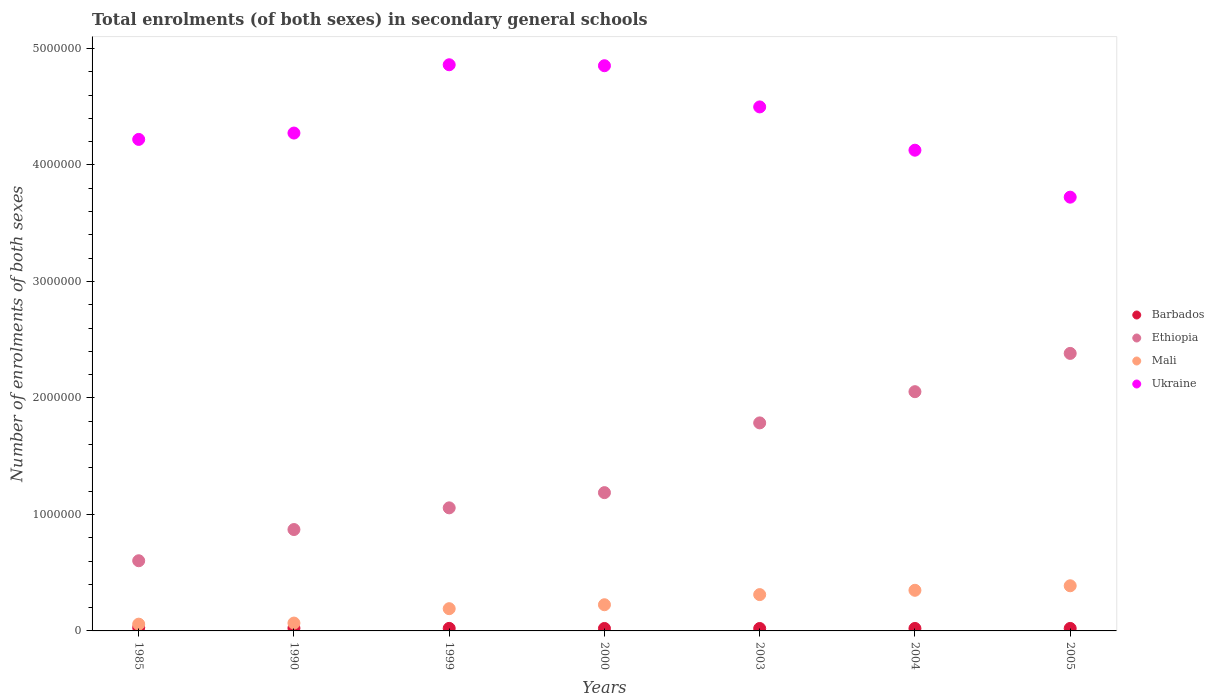Is the number of dotlines equal to the number of legend labels?
Keep it short and to the point. Yes. What is the number of enrolments in secondary schools in Ukraine in 2005?
Offer a very short reply. 3.72e+06. Across all years, what is the maximum number of enrolments in secondary schools in Ethiopia?
Your answer should be very brief. 2.38e+06. Across all years, what is the minimum number of enrolments in secondary schools in Mali?
Give a very brief answer. 5.81e+04. In which year was the number of enrolments in secondary schools in Ethiopia maximum?
Make the answer very short. 2005. What is the total number of enrolments in secondary schools in Barbados in the graph?
Your answer should be very brief. 1.59e+05. What is the difference between the number of enrolments in secondary schools in Mali in 2003 and that in 2005?
Your response must be concise. -7.58e+04. What is the difference between the number of enrolments in secondary schools in Ukraine in 2004 and the number of enrolments in secondary schools in Barbados in 1999?
Your answer should be compact. 4.10e+06. What is the average number of enrolments in secondary schools in Ukraine per year?
Your response must be concise. 4.36e+06. In the year 2004, what is the difference between the number of enrolments in secondary schools in Ethiopia and number of enrolments in secondary schools in Mali?
Provide a short and direct response. 1.70e+06. What is the ratio of the number of enrolments in secondary schools in Ethiopia in 2004 to that in 2005?
Your answer should be compact. 0.86. Is the number of enrolments in secondary schools in Ethiopia in 1999 less than that in 2000?
Offer a terse response. Yes. Is the difference between the number of enrolments in secondary schools in Ethiopia in 1985 and 2004 greater than the difference between the number of enrolments in secondary schools in Mali in 1985 and 2004?
Offer a terse response. No. What is the difference between the highest and the second highest number of enrolments in secondary schools in Mali?
Provide a short and direct response. 3.88e+04. What is the difference between the highest and the lowest number of enrolments in secondary schools in Mali?
Your answer should be compact. 3.29e+05. In how many years, is the number of enrolments in secondary schools in Mali greater than the average number of enrolments in secondary schools in Mali taken over all years?
Offer a very short reply. 3. Is the sum of the number of enrolments in secondary schools in Mali in 2003 and 2005 greater than the maximum number of enrolments in secondary schools in Ukraine across all years?
Give a very brief answer. No. Is it the case that in every year, the sum of the number of enrolments in secondary schools in Ethiopia and number of enrolments in secondary schools in Barbados  is greater than the number of enrolments in secondary schools in Mali?
Provide a short and direct response. Yes. Does the number of enrolments in secondary schools in Ethiopia monotonically increase over the years?
Make the answer very short. Yes. Is the number of enrolments in secondary schools in Ukraine strictly less than the number of enrolments in secondary schools in Barbados over the years?
Offer a terse response. No. How many years are there in the graph?
Ensure brevity in your answer.  7. What is the difference between two consecutive major ticks on the Y-axis?
Provide a short and direct response. 1.00e+06. Are the values on the major ticks of Y-axis written in scientific E-notation?
Ensure brevity in your answer.  No. Does the graph contain any zero values?
Offer a very short reply. No. Where does the legend appear in the graph?
Provide a succinct answer. Center right. What is the title of the graph?
Your answer should be compact. Total enrolments (of both sexes) in secondary general schools. Does "Bulgaria" appear as one of the legend labels in the graph?
Provide a succinct answer. No. What is the label or title of the X-axis?
Keep it short and to the point. Years. What is the label or title of the Y-axis?
Your answer should be compact. Number of enrolments of both sexes. What is the Number of enrolments of both sexes in Barbados in 1985?
Give a very brief answer. 2.87e+04. What is the Number of enrolments of both sexes in Ethiopia in 1985?
Keep it short and to the point. 6.02e+05. What is the Number of enrolments of both sexes of Mali in 1985?
Keep it short and to the point. 5.81e+04. What is the Number of enrolments of both sexes of Ukraine in 1985?
Ensure brevity in your answer.  4.22e+06. What is the Number of enrolments of both sexes of Barbados in 1990?
Your answer should be very brief. 2.40e+04. What is the Number of enrolments of both sexes of Ethiopia in 1990?
Give a very brief answer. 8.70e+05. What is the Number of enrolments of both sexes of Mali in 1990?
Offer a very short reply. 6.73e+04. What is the Number of enrolments of both sexes in Ukraine in 1990?
Your answer should be compact. 4.27e+06. What is the Number of enrolments of both sexes in Barbados in 1999?
Keep it short and to the point. 2.18e+04. What is the Number of enrolments of both sexes in Ethiopia in 1999?
Keep it short and to the point. 1.06e+06. What is the Number of enrolments of both sexes of Mali in 1999?
Your answer should be compact. 1.91e+05. What is the Number of enrolments of both sexes of Ukraine in 1999?
Your answer should be compact. 4.86e+06. What is the Number of enrolments of both sexes in Barbados in 2000?
Give a very brief answer. 2.10e+04. What is the Number of enrolments of both sexes of Ethiopia in 2000?
Provide a short and direct response. 1.19e+06. What is the Number of enrolments of both sexes of Mali in 2000?
Provide a succinct answer. 2.25e+05. What is the Number of enrolments of both sexes in Ukraine in 2000?
Offer a terse response. 4.85e+06. What is the Number of enrolments of both sexes in Barbados in 2003?
Your response must be concise. 2.08e+04. What is the Number of enrolments of both sexes of Ethiopia in 2003?
Your answer should be very brief. 1.79e+06. What is the Number of enrolments of both sexes in Mali in 2003?
Keep it short and to the point. 3.12e+05. What is the Number of enrolments of both sexes in Ukraine in 2003?
Your answer should be compact. 4.50e+06. What is the Number of enrolments of both sexes in Barbados in 2004?
Offer a very short reply. 2.12e+04. What is the Number of enrolments of both sexes of Ethiopia in 2004?
Your answer should be very brief. 2.05e+06. What is the Number of enrolments of both sexes of Mali in 2004?
Ensure brevity in your answer.  3.49e+05. What is the Number of enrolments of both sexes of Ukraine in 2004?
Make the answer very short. 4.13e+06. What is the Number of enrolments of both sexes of Barbados in 2005?
Your answer should be very brief. 2.13e+04. What is the Number of enrolments of both sexes of Ethiopia in 2005?
Ensure brevity in your answer.  2.38e+06. What is the Number of enrolments of both sexes of Mali in 2005?
Offer a very short reply. 3.88e+05. What is the Number of enrolments of both sexes in Ukraine in 2005?
Provide a short and direct response. 3.72e+06. Across all years, what is the maximum Number of enrolments of both sexes in Barbados?
Give a very brief answer. 2.87e+04. Across all years, what is the maximum Number of enrolments of both sexes of Ethiopia?
Your answer should be compact. 2.38e+06. Across all years, what is the maximum Number of enrolments of both sexes of Mali?
Give a very brief answer. 3.88e+05. Across all years, what is the maximum Number of enrolments of both sexes in Ukraine?
Keep it short and to the point. 4.86e+06. Across all years, what is the minimum Number of enrolments of both sexes of Barbados?
Offer a terse response. 2.08e+04. Across all years, what is the minimum Number of enrolments of both sexes in Ethiopia?
Give a very brief answer. 6.02e+05. Across all years, what is the minimum Number of enrolments of both sexes of Mali?
Provide a short and direct response. 5.81e+04. Across all years, what is the minimum Number of enrolments of both sexes of Ukraine?
Provide a succinct answer. 3.72e+06. What is the total Number of enrolments of both sexes of Barbados in the graph?
Make the answer very short. 1.59e+05. What is the total Number of enrolments of both sexes of Ethiopia in the graph?
Offer a terse response. 9.94e+06. What is the total Number of enrolments of both sexes in Mali in the graph?
Give a very brief answer. 1.59e+06. What is the total Number of enrolments of both sexes in Ukraine in the graph?
Your answer should be compact. 3.06e+07. What is the difference between the Number of enrolments of both sexes in Barbados in 1985 and that in 1990?
Give a very brief answer. 4691. What is the difference between the Number of enrolments of both sexes in Ethiopia in 1985 and that in 1990?
Provide a succinct answer. -2.68e+05. What is the difference between the Number of enrolments of both sexes of Mali in 1985 and that in 1990?
Your response must be concise. -9262. What is the difference between the Number of enrolments of both sexes of Ukraine in 1985 and that in 1990?
Give a very brief answer. -5.45e+04. What is the difference between the Number of enrolments of both sexes in Barbados in 1985 and that in 1999?
Your response must be concise. 6854. What is the difference between the Number of enrolments of both sexes of Ethiopia in 1985 and that in 1999?
Make the answer very short. -4.54e+05. What is the difference between the Number of enrolments of both sexes in Mali in 1985 and that in 1999?
Ensure brevity in your answer.  -1.33e+05. What is the difference between the Number of enrolments of both sexes in Ukraine in 1985 and that in 1999?
Ensure brevity in your answer.  -6.41e+05. What is the difference between the Number of enrolments of both sexes in Barbados in 1985 and that in 2000?
Offer a very short reply. 7679. What is the difference between the Number of enrolments of both sexes of Ethiopia in 1985 and that in 2000?
Offer a terse response. -5.85e+05. What is the difference between the Number of enrolments of both sexes in Mali in 1985 and that in 2000?
Provide a short and direct response. -1.67e+05. What is the difference between the Number of enrolments of both sexes of Ukraine in 1985 and that in 2000?
Offer a terse response. -6.32e+05. What is the difference between the Number of enrolments of both sexes in Barbados in 1985 and that in 2003?
Provide a succinct answer. 7857. What is the difference between the Number of enrolments of both sexes in Ethiopia in 1985 and that in 2003?
Make the answer very short. -1.18e+06. What is the difference between the Number of enrolments of both sexes in Mali in 1985 and that in 2003?
Provide a succinct answer. -2.54e+05. What is the difference between the Number of enrolments of both sexes in Ukraine in 1985 and that in 2003?
Provide a succinct answer. -2.79e+05. What is the difference between the Number of enrolments of both sexes in Barbados in 1985 and that in 2004?
Your answer should be compact. 7473. What is the difference between the Number of enrolments of both sexes in Ethiopia in 1985 and that in 2004?
Provide a short and direct response. -1.45e+06. What is the difference between the Number of enrolments of both sexes in Mali in 1985 and that in 2004?
Make the answer very short. -2.91e+05. What is the difference between the Number of enrolments of both sexes of Ukraine in 1985 and that in 2004?
Give a very brief answer. 9.27e+04. What is the difference between the Number of enrolments of both sexes of Barbados in 1985 and that in 2005?
Your response must be concise. 7350. What is the difference between the Number of enrolments of both sexes of Ethiopia in 1985 and that in 2005?
Provide a short and direct response. -1.78e+06. What is the difference between the Number of enrolments of both sexes of Mali in 1985 and that in 2005?
Provide a short and direct response. -3.29e+05. What is the difference between the Number of enrolments of both sexes in Ukraine in 1985 and that in 2005?
Your answer should be very brief. 4.96e+05. What is the difference between the Number of enrolments of both sexes in Barbados in 1990 and that in 1999?
Offer a very short reply. 2163. What is the difference between the Number of enrolments of both sexes in Ethiopia in 1990 and that in 1999?
Keep it short and to the point. -1.86e+05. What is the difference between the Number of enrolments of both sexes in Mali in 1990 and that in 1999?
Provide a short and direct response. -1.24e+05. What is the difference between the Number of enrolments of both sexes of Ukraine in 1990 and that in 1999?
Your answer should be compact. -5.86e+05. What is the difference between the Number of enrolments of both sexes in Barbados in 1990 and that in 2000?
Keep it short and to the point. 2988. What is the difference between the Number of enrolments of both sexes in Ethiopia in 1990 and that in 2000?
Provide a short and direct response. -3.17e+05. What is the difference between the Number of enrolments of both sexes in Mali in 1990 and that in 2000?
Give a very brief answer. -1.57e+05. What is the difference between the Number of enrolments of both sexes of Ukraine in 1990 and that in 2000?
Give a very brief answer. -5.78e+05. What is the difference between the Number of enrolments of both sexes of Barbados in 1990 and that in 2003?
Provide a short and direct response. 3166. What is the difference between the Number of enrolments of both sexes of Ethiopia in 1990 and that in 2003?
Offer a terse response. -9.15e+05. What is the difference between the Number of enrolments of both sexes in Mali in 1990 and that in 2003?
Provide a succinct answer. -2.44e+05. What is the difference between the Number of enrolments of both sexes of Ukraine in 1990 and that in 2003?
Ensure brevity in your answer.  -2.24e+05. What is the difference between the Number of enrolments of both sexes in Barbados in 1990 and that in 2004?
Make the answer very short. 2782. What is the difference between the Number of enrolments of both sexes in Ethiopia in 1990 and that in 2004?
Your answer should be very brief. -1.18e+06. What is the difference between the Number of enrolments of both sexes of Mali in 1990 and that in 2004?
Provide a succinct answer. -2.81e+05. What is the difference between the Number of enrolments of both sexes of Ukraine in 1990 and that in 2004?
Make the answer very short. 1.47e+05. What is the difference between the Number of enrolments of both sexes of Barbados in 1990 and that in 2005?
Your answer should be compact. 2659. What is the difference between the Number of enrolments of both sexes of Ethiopia in 1990 and that in 2005?
Give a very brief answer. -1.51e+06. What is the difference between the Number of enrolments of both sexes in Mali in 1990 and that in 2005?
Your answer should be compact. -3.20e+05. What is the difference between the Number of enrolments of both sexes in Ukraine in 1990 and that in 2005?
Offer a terse response. 5.50e+05. What is the difference between the Number of enrolments of both sexes of Barbados in 1999 and that in 2000?
Your answer should be very brief. 825. What is the difference between the Number of enrolments of both sexes of Ethiopia in 1999 and that in 2000?
Provide a succinct answer. -1.31e+05. What is the difference between the Number of enrolments of both sexes of Mali in 1999 and that in 2000?
Ensure brevity in your answer.  -3.38e+04. What is the difference between the Number of enrolments of both sexes of Ukraine in 1999 and that in 2000?
Your answer should be very brief. 8251. What is the difference between the Number of enrolments of both sexes of Barbados in 1999 and that in 2003?
Give a very brief answer. 1003. What is the difference between the Number of enrolments of both sexes of Ethiopia in 1999 and that in 2003?
Give a very brief answer. -7.29e+05. What is the difference between the Number of enrolments of both sexes of Mali in 1999 and that in 2003?
Make the answer very short. -1.21e+05. What is the difference between the Number of enrolments of both sexes of Ukraine in 1999 and that in 2003?
Provide a succinct answer. 3.62e+05. What is the difference between the Number of enrolments of both sexes of Barbados in 1999 and that in 2004?
Make the answer very short. 619. What is the difference between the Number of enrolments of both sexes in Ethiopia in 1999 and that in 2004?
Make the answer very short. -9.97e+05. What is the difference between the Number of enrolments of both sexes of Mali in 1999 and that in 2004?
Ensure brevity in your answer.  -1.58e+05. What is the difference between the Number of enrolments of both sexes in Ukraine in 1999 and that in 2004?
Offer a terse response. 7.33e+05. What is the difference between the Number of enrolments of both sexes of Barbados in 1999 and that in 2005?
Make the answer very short. 496. What is the difference between the Number of enrolments of both sexes of Ethiopia in 1999 and that in 2005?
Your answer should be very brief. -1.33e+06. What is the difference between the Number of enrolments of both sexes of Mali in 1999 and that in 2005?
Keep it short and to the point. -1.97e+05. What is the difference between the Number of enrolments of both sexes in Ukraine in 1999 and that in 2005?
Make the answer very short. 1.14e+06. What is the difference between the Number of enrolments of both sexes in Barbados in 2000 and that in 2003?
Your answer should be compact. 178. What is the difference between the Number of enrolments of both sexes in Ethiopia in 2000 and that in 2003?
Your answer should be compact. -5.99e+05. What is the difference between the Number of enrolments of both sexes in Mali in 2000 and that in 2003?
Offer a very short reply. -8.70e+04. What is the difference between the Number of enrolments of both sexes in Ukraine in 2000 and that in 2003?
Provide a succinct answer. 3.54e+05. What is the difference between the Number of enrolments of both sexes of Barbados in 2000 and that in 2004?
Provide a succinct answer. -206. What is the difference between the Number of enrolments of both sexes in Ethiopia in 2000 and that in 2004?
Provide a succinct answer. -8.67e+05. What is the difference between the Number of enrolments of both sexes in Mali in 2000 and that in 2004?
Give a very brief answer. -1.24e+05. What is the difference between the Number of enrolments of both sexes of Ukraine in 2000 and that in 2004?
Offer a very short reply. 7.25e+05. What is the difference between the Number of enrolments of both sexes of Barbados in 2000 and that in 2005?
Your answer should be very brief. -329. What is the difference between the Number of enrolments of both sexes in Ethiopia in 2000 and that in 2005?
Keep it short and to the point. -1.20e+06. What is the difference between the Number of enrolments of both sexes of Mali in 2000 and that in 2005?
Give a very brief answer. -1.63e+05. What is the difference between the Number of enrolments of both sexes of Ukraine in 2000 and that in 2005?
Your answer should be very brief. 1.13e+06. What is the difference between the Number of enrolments of both sexes in Barbados in 2003 and that in 2004?
Your answer should be compact. -384. What is the difference between the Number of enrolments of both sexes in Ethiopia in 2003 and that in 2004?
Offer a terse response. -2.68e+05. What is the difference between the Number of enrolments of both sexes of Mali in 2003 and that in 2004?
Provide a short and direct response. -3.70e+04. What is the difference between the Number of enrolments of both sexes in Ukraine in 2003 and that in 2004?
Offer a very short reply. 3.72e+05. What is the difference between the Number of enrolments of both sexes in Barbados in 2003 and that in 2005?
Make the answer very short. -507. What is the difference between the Number of enrolments of both sexes of Ethiopia in 2003 and that in 2005?
Your answer should be compact. -5.96e+05. What is the difference between the Number of enrolments of both sexes in Mali in 2003 and that in 2005?
Provide a short and direct response. -7.58e+04. What is the difference between the Number of enrolments of both sexes of Ukraine in 2003 and that in 2005?
Your response must be concise. 7.75e+05. What is the difference between the Number of enrolments of both sexes in Barbados in 2004 and that in 2005?
Ensure brevity in your answer.  -123. What is the difference between the Number of enrolments of both sexes of Ethiopia in 2004 and that in 2005?
Make the answer very short. -3.29e+05. What is the difference between the Number of enrolments of both sexes in Mali in 2004 and that in 2005?
Your answer should be very brief. -3.88e+04. What is the difference between the Number of enrolments of both sexes of Ukraine in 2004 and that in 2005?
Your response must be concise. 4.03e+05. What is the difference between the Number of enrolments of both sexes of Barbados in 1985 and the Number of enrolments of both sexes of Ethiopia in 1990?
Give a very brief answer. -8.42e+05. What is the difference between the Number of enrolments of both sexes of Barbados in 1985 and the Number of enrolments of both sexes of Mali in 1990?
Offer a very short reply. -3.86e+04. What is the difference between the Number of enrolments of both sexes of Barbados in 1985 and the Number of enrolments of both sexes of Ukraine in 1990?
Your answer should be very brief. -4.24e+06. What is the difference between the Number of enrolments of both sexes of Ethiopia in 1985 and the Number of enrolments of both sexes of Mali in 1990?
Your answer should be compact. 5.35e+05. What is the difference between the Number of enrolments of both sexes of Ethiopia in 1985 and the Number of enrolments of both sexes of Ukraine in 1990?
Give a very brief answer. -3.67e+06. What is the difference between the Number of enrolments of both sexes of Mali in 1985 and the Number of enrolments of both sexes of Ukraine in 1990?
Provide a short and direct response. -4.22e+06. What is the difference between the Number of enrolments of both sexes of Barbados in 1985 and the Number of enrolments of both sexes of Ethiopia in 1999?
Your answer should be very brief. -1.03e+06. What is the difference between the Number of enrolments of both sexes of Barbados in 1985 and the Number of enrolments of both sexes of Mali in 1999?
Keep it short and to the point. -1.62e+05. What is the difference between the Number of enrolments of both sexes in Barbados in 1985 and the Number of enrolments of both sexes in Ukraine in 1999?
Your response must be concise. -4.83e+06. What is the difference between the Number of enrolments of both sexes in Ethiopia in 1985 and the Number of enrolments of both sexes in Mali in 1999?
Your response must be concise. 4.11e+05. What is the difference between the Number of enrolments of both sexes in Ethiopia in 1985 and the Number of enrolments of both sexes in Ukraine in 1999?
Offer a terse response. -4.26e+06. What is the difference between the Number of enrolments of both sexes in Mali in 1985 and the Number of enrolments of both sexes in Ukraine in 1999?
Keep it short and to the point. -4.80e+06. What is the difference between the Number of enrolments of both sexes of Barbados in 1985 and the Number of enrolments of both sexes of Ethiopia in 2000?
Provide a succinct answer. -1.16e+06. What is the difference between the Number of enrolments of both sexes of Barbados in 1985 and the Number of enrolments of both sexes of Mali in 2000?
Provide a succinct answer. -1.96e+05. What is the difference between the Number of enrolments of both sexes in Barbados in 1985 and the Number of enrolments of both sexes in Ukraine in 2000?
Give a very brief answer. -4.82e+06. What is the difference between the Number of enrolments of both sexes of Ethiopia in 1985 and the Number of enrolments of both sexes of Mali in 2000?
Give a very brief answer. 3.78e+05. What is the difference between the Number of enrolments of both sexes of Ethiopia in 1985 and the Number of enrolments of both sexes of Ukraine in 2000?
Provide a succinct answer. -4.25e+06. What is the difference between the Number of enrolments of both sexes in Mali in 1985 and the Number of enrolments of both sexes in Ukraine in 2000?
Offer a very short reply. -4.79e+06. What is the difference between the Number of enrolments of both sexes in Barbados in 1985 and the Number of enrolments of both sexes in Ethiopia in 2003?
Keep it short and to the point. -1.76e+06. What is the difference between the Number of enrolments of both sexes of Barbados in 1985 and the Number of enrolments of both sexes of Mali in 2003?
Ensure brevity in your answer.  -2.83e+05. What is the difference between the Number of enrolments of both sexes in Barbados in 1985 and the Number of enrolments of both sexes in Ukraine in 2003?
Offer a terse response. -4.47e+06. What is the difference between the Number of enrolments of both sexes in Ethiopia in 1985 and the Number of enrolments of both sexes in Mali in 2003?
Ensure brevity in your answer.  2.91e+05. What is the difference between the Number of enrolments of both sexes in Ethiopia in 1985 and the Number of enrolments of both sexes in Ukraine in 2003?
Your response must be concise. -3.90e+06. What is the difference between the Number of enrolments of both sexes of Mali in 1985 and the Number of enrolments of both sexes of Ukraine in 2003?
Offer a very short reply. -4.44e+06. What is the difference between the Number of enrolments of both sexes in Barbados in 1985 and the Number of enrolments of both sexes in Ethiopia in 2004?
Keep it short and to the point. -2.02e+06. What is the difference between the Number of enrolments of both sexes of Barbados in 1985 and the Number of enrolments of both sexes of Mali in 2004?
Provide a succinct answer. -3.20e+05. What is the difference between the Number of enrolments of both sexes in Barbados in 1985 and the Number of enrolments of both sexes in Ukraine in 2004?
Provide a succinct answer. -4.10e+06. What is the difference between the Number of enrolments of both sexes in Ethiopia in 1985 and the Number of enrolments of both sexes in Mali in 2004?
Make the answer very short. 2.54e+05. What is the difference between the Number of enrolments of both sexes of Ethiopia in 1985 and the Number of enrolments of both sexes of Ukraine in 2004?
Give a very brief answer. -3.52e+06. What is the difference between the Number of enrolments of both sexes of Mali in 1985 and the Number of enrolments of both sexes of Ukraine in 2004?
Ensure brevity in your answer.  -4.07e+06. What is the difference between the Number of enrolments of both sexes in Barbados in 1985 and the Number of enrolments of both sexes in Ethiopia in 2005?
Give a very brief answer. -2.35e+06. What is the difference between the Number of enrolments of both sexes in Barbados in 1985 and the Number of enrolments of both sexes in Mali in 2005?
Offer a terse response. -3.59e+05. What is the difference between the Number of enrolments of both sexes of Barbados in 1985 and the Number of enrolments of both sexes of Ukraine in 2005?
Your response must be concise. -3.69e+06. What is the difference between the Number of enrolments of both sexes of Ethiopia in 1985 and the Number of enrolments of both sexes of Mali in 2005?
Give a very brief answer. 2.15e+05. What is the difference between the Number of enrolments of both sexes in Ethiopia in 1985 and the Number of enrolments of both sexes in Ukraine in 2005?
Make the answer very short. -3.12e+06. What is the difference between the Number of enrolments of both sexes in Mali in 1985 and the Number of enrolments of both sexes in Ukraine in 2005?
Provide a short and direct response. -3.67e+06. What is the difference between the Number of enrolments of both sexes in Barbados in 1990 and the Number of enrolments of both sexes in Ethiopia in 1999?
Offer a very short reply. -1.03e+06. What is the difference between the Number of enrolments of both sexes in Barbados in 1990 and the Number of enrolments of both sexes in Mali in 1999?
Offer a terse response. -1.67e+05. What is the difference between the Number of enrolments of both sexes in Barbados in 1990 and the Number of enrolments of both sexes in Ukraine in 1999?
Provide a succinct answer. -4.84e+06. What is the difference between the Number of enrolments of both sexes of Ethiopia in 1990 and the Number of enrolments of both sexes of Mali in 1999?
Your response must be concise. 6.79e+05. What is the difference between the Number of enrolments of both sexes in Ethiopia in 1990 and the Number of enrolments of both sexes in Ukraine in 1999?
Your response must be concise. -3.99e+06. What is the difference between the Number of enrolments of both sexes of Mali in 1990 and the Number of enrolments of both sexes of Ukraine in 1999?
Keep it short and to the point. -4.79e+06. What is the difference between the Number of enrolments of both sexes of Barbados in 1990 and the Number of enrolments of both sexes of Ethiopia in 2000?
Make the answer very short. -1.16e+06. What is the difference between the Number of enrolments of both sexes in Barbados in 1990 and the Number of enrolments of both sexes in Mali in 2000?
Offer a terse response. -2.01e+05. What is the difference between the Number of enrolments of both sexes in Barbados in 1990 and the Number of enrolments of both sexes in Ukraine in 2000?
Ensure brevity in your answer.  -4.83e+06. What is the difference between the Number of enrolments of both sexes in Ethiopia in 1990 and the Number of enrolments of both sexes in Mali in 2000?
Ensure brevity in your answer.  6.46e+05. What is the difference between the Number of enrolments of both sexes in Ethiopia in 1990 and the Number of enrolments of both sexes in Ukraine in 2000?
Your answer should be very brief. -3.98e+06. What is the difference between the Number of enrolments of both sexes of Mali in 1990 and the Number of enrolments of both sexes of Ukraine in 2000?
Offer a terse response. -4.78e+06. What is the difference between the Number of enrolments of both sexes in Barbados in 1990 and the Number of enrolments of both sexes in Ethiopia in 2003?
Keep it short and to the point. -1.76e+06. What is the difference between the Number of enrolments of both sexes in Barbados in 1990 and the Number of enrolments of both sexes in Mali in 2003?
Ensure brevity in your answer.  -2.88e+05. What is the difference between the Number of enrolments of both sexes in Barbados in 1990 and the Number of enrolments of both sexes in Ukraine in 2003?
Offer a terse response. -4.47e+06. What is the difference between the Number of enrolments of both sexes of Ethiopia in 1990 and the Number of enrolments of both sexes of Mali in 2003?
Keep it short and to the point. 5.59e+05. What is the difference between the Number of enrolments of both sexes in Ethiopia in 1990 and the Number of enrolments of both sexes in Ukraine in 2003?
Give a very brief answer. -3.63e+06. What is the difference between the Number of enrolments of both sexes of Mali in 1990 and the Number of enrolments of both sexes of Ukraine in 2003?
Ensure brevity in your answer.  -4.43e+06. What is the difference between the Number of enrolments of both sexes of Barbados in 1990 and the Number of enrolments of both sexes of Ethiopia in 2004?
Make the answer very short. -2.03e+06. What is the difference between the Number of enrolments of both sexes of Barbados in 1990 and the Number of enrolments of both sexes of Mali in 2004?
Offer a very short reply. -3.25e+05. What is the difference between the Number of enrolments of both sexes of Barbados in 1990 and the Number of enrolments of both sexes of Ukraine in 2004?
Ensure brevity in your answer.  -4.10e+06. What is the difference between the Number of enrolments of both sexes in Ethiopia in 1990 and the Number of enrolments of both sexes in Mali in 2004?
Your response must be concise. 5.22e+05. What is the difference between the Number of enrolments of both sexes of Ethiopia in 1990 and the Number of enrolments of both sexes of Ukraine in 2004?
Your answer should be compact. -3.26e+06. What is the difference between the Number of enrolments of both sexes of Mali in 1990 and the Number of enrolments of both sexes of Ukraine in 2004?
Give a very brief answer. -4.06e+06. What is the difference between the Number of enrolments of both sexes in Barbados in 1990 and the Number of enrolments of both sexes in Ethiopia in 2005?
Offer a very short reply. -2.36e+06. What is the difference between the Number of enrolments of both sexes in Barbados in 1990 and the Number of enrolments of both sexes in Mali in 2005?
Give a very brief answer. -3.64e+05. What is the difference between the Number of enrolments of both sexes in Barbados in 1990 and the Number of enrolments of both sexes in Ukraine in 2005?
Your answer should be very brief. -3.70e+06. What is the difference between the Number of enrolments of both sexes of Ethiopia in 1990 and the Number of enrolments of both sexes of Mali in 2005?
Your answer should be very brief. 4.83e+05. What is the difference between the Number of enrolments of both sexes of Ethiopia in 1990 and the Number of enrolments of both sexes of Ukraine in 2005?
Your response must be concise. -2.85e+06. What is the difference between the Number of enrolments of both sexes in Mali in 1990 and the Number of enrolments of both sexes in Ukraine in 2005?
Offer a very short reply. -3.66e+06. What is the difference between the Number of enrolments of both sexes of Barbados in 1999 and the Number of enrolments of both sexes of Ethiopia in 2000?
Give a very brief answer. -1.17e+06. What is the difference between the Number of enrolments of both sexes in Barbados in 1999 and the Number of enrolments of both sexes in Mali in 2000?
Your response must be concise. -2.03e+05. What is the difference between the Number of enrolments of both sexes in Barbados in 1999 and the Number of enrolments of both sexes in Ukraine in 2000?
Make the answer very short. -4.83e+06. What is the difference between the Number of enrolments of both sexes of Ethiopia in 1999 and the Number of enrolments of both sexes of Mali in 2000?
Keep it short and to the point. 8.32e+05. What is the difference between the Number of enrolments of both sexes of Ethiopia in 1999 and the Number of enrolments of both sexes of Ukraine in 2000?
Offer a very short reply. -3.80e+06. What is the difference between the Number of enrolments of both sexes in Mali in 1999 and the Number of enrolments of both sexes in Ukraine in 2000?
Make the answer very short. -4.66e+06. What is the difference between the Number of enrolments of both sexes in Barbados in 1999 and the Number of enrolments of both sexes in Ethiopia in 2003?
Give a very brief answer. -1.76e+06. What is the difference between the Number of enrolments of both sexes of Barbados in 1999 and the Number of enrolments of both sexes of Mali in 2003?
Your response must be concise. -2.90e+05. What is the difference between the Number of enrolments of both sexes of Barbados in 1999 and the Number of enrolments of both sexes of Ukraine in 2003?
Offer a very short reply. -4.48e+06. What is the difference between the Number of enrolments of both sexes in Ethiopia in 1999 and the Number of enrolments of both sexes in Mali in 2003?
Provide a succinct answer. 7.45e+05. What is the difference between the Number of enrolments of both sexes of Ethiopia in 1999 and the Number of enrolments of both sexes of Ukraine in 2003?
Make the answer very short. -3.44e+06. What is the difference between the Number of enrolments of both sexes in Mali in 1999 and the Number of enrolments of both sexes in Ukraine in 2003?
Your response must be concise. -4.31e+06. What is the difference between the Number of enrolments of both sexes of Barbados in 1999 and the Number of enrolments of both sexes of Ethiopia in 2004?
Keep it short and to the point. -2.03e+06. What is the difference between the Number of enrolments of both sexes in Barbados in 1999 and the Number of enrolments of both sexes in Mali in 2004?
Make the answer very short. -3.27e+05. What is the difference between the Number of enrolments of both sexes of Barbados in 1999 and the Number of enrolments of both sexes of Ukraine in 2004?
Your answer should be very brief. -4.10e+06. What is the difference between the Number of enrolments of both sexes in Ethiopia in 1999 and the Number of enrolments of both sexes in Mali in 2004?
Keep it short and to the point. 7.08e+05. What is the difference between the Number of enrolments of both sexes of Ethiopia in 1999 and the Number of enrolments of both sexes of Ukraine in 2004?
Make the answer very short. -3.07e+06. What is the difference between the Number of enrolments of both sexes of Mali in 1999 and the Number of enrolments of both sexes of Ukraine in 2004?
Your response must be concise. -3.94e+06. What is the difference between the Number of enrolments of both sexes of Barbados in 1999 and the Number of enrolments of both sexes of Ethiopia in 2005?
Provide a short and direct response. -2.36e+06. What is the difference between the Number of enrolments of both sexes in Barbados in 1999 and the Number of enrolments of both sexes in Mali in 2005?
Your answer should be compact. -3.66e+05. What is the difference between the Number of enrolments of both sexes of Barbados in 1999 and the Number of enrolments of both sexes of Ukraine in 2005?
Offer a terse response. -3.70e+06. What is the difference between the Number of enrolments of both sexes in Ethiopia in 1999 and the Number of enrolments of both sexes in Mali in 2005?
Your response must be concise. 6.69e+05. What is the difference between the Number of enrolments of both sexes in Ethiopia in 1999 and the Number of enrolments of both sexes in Ukraine in 2005?
Provide a succinct answer. -2.67e+06. What is the difference between the Number of enrolments of both sexes in Mali in 1999 and the Number of enrolments of both sexes in Ukraine in 2005?
Provide a short and direct response. -3.53e+06. What is the difference between the Number of enrolments of both sexes in Barbados in 2000 and the Number of enrolments of both sexes in Ethiopia in 2003?
Offer a very short reply. -1.76e+06. What is the difference between the Number of enrolments of both sexes of Barbados in 2000 and the Number of enrolments of both sexes of Mali in 2003?
Offer a very short reply. -2.91e+05. What is the difference between the Number of enrolments of both sexes of Barbados in 2000 and the Number of enrolments of both sexes of Ukraine in 2003?
Ensure brevity in your answer.  -4.48e+06. What is the difference between the Number of enrolments of both sexes in Ethiopia in 2000 and the Number of enrolments of both sexes in Mali in 2003?
Offer a terse response. 8.75e+05. What is the difference between the Number of enrolments of both sexes of Ethiopia in 2000 and the Number of enrolments of both sexes of Ukraine in 2003?
Offer a very short reply. -3.31e+06. What is the difference between the Number of enrolments of both sexes in Mali in 2000 and the Number of enrolments of both sexes in Ukraine in 2003?
Provide a succinct answer. -4.27e+06. What is the difference between the Number of enrolments of both sexes of Barbados in 2000 and the Number of enrolments of both sexes of Ethiopia in 2004?
Your answer should be very brief. -2.03e+06. What is the difference between the Number of enrolments of both sexes of Barbados in 2000 and the Number of enrolments of both sexes of Mali in 2004?
Your answer should be compact. -3.28e+05. What is the difference between the Number of enrolments of both sexes in Barbados in 2000 and the Number of enrolments of both sexes in Ukraine in 2004?
Make the answer very short. -4.11e+06. What is the difference between the Number of enrolments of both sexes in Ethiopia in 2000 and the Number of enrolments of both sexes in Mali in 2004?
Offer a terse response. 8.38e+05. What is the difference between the Number of enrolments of both sexes in Ethiopia in 2000 and the Number of enrolments of both sexes in Ukraine in 2004?
Your response must be concise. -2.94e+06. What is the difference between the Number of enrolments of both sexes in Mali in 2000 and the Number of enrolments of both sexes in Ukraine in 2004?
Provide a succinct answer. -3.90e+06. What is the difference between the Number of enrolments of both sexes in Barbados in 2000 and the Number of enrolments of both sexes in Ethiopia in 2005?
Your answer should be very brief. -2.36e+06. What is the difference between the Number of enrolments of both sexes in Barbados in 2000 and the Number of enrolments of both sexes in Mali in 2005?
Offer a terse response. -3.67e+05. What is the difference between the Number of enrolments of both sexes of Barbados in 2000 and the Number of enrolments of both sexes of Ukraine in 2005?
Give a very brief answer. -3.70e+06. What is the difference between the Number of enrolments of both sexes of Ethiopia in 2000 and the Number of enrolments of both sexes of Mali in 2005?
Keep it short and to the point. 7.99e+05. What is the difference between the Number of enrolments of both sexes in Ethiopia in 2000 and the Number of enrolments of both sexes in Ukraine in 2005?
Provide a succinct answer. -2.54e+06. What is the difference between the Number of enrolments of both sexes in Mali in 2000 and the Number of enrolments of both sexes in Ukraine in 2005?
Offer a terse response. -3.50e+06. What is the difference between the Number of enrolments of both sexes in Barbados in 2003 and the Number of enrolments of both sexes in Ethiopia in 2004?
Provide a short and direct response. -2.03e+06. What is the difference between the Number of enrolments of both sexes of Barbados in 2003 and the Number of enrolments of both sexes of Mali in 2004?
Your answer should be compact. -3.28e+05. What is the difference between the Number of enrolments of both sexes of Barbados in 2003 and the Number of enrolments of both sexes of Ukraine in 2004?
Provide a succinct answer. -4.11e+06. What is the difference between the Number of enrolments of both sexes in Ethiopia in 2003 and the Number of enrolments of both sexes in Mali in 2004?
Offer a very short reply. 1.44e+06. What is the difference between the Number of enrolments of both sexes in Ethiopia in 2003 and the Number of enrolments of both sexes in Ukraine in 2004?
Your answer should be very brief. -2.34e+06. What is the difference between the Number of enrolments of both sexes of Mali in 2003 and the Number of enrolments of both sexes of Ukraine in 2004?
Offer a very short reply. -3.81e+06. What is the difference between the Number of enrolments of both sexes in Barbados in 2003 and the Number of enrolments of both sexes in Ethiopia in 2005?
Your answer should be compact. -2.36e+06. What is the difference between the Number of enrolments of both sexes in Barbados in 2003 and the Number of enrolments of both sexes in Mali in 2005?
Ensure brevity in your answer.  -3.67e+05. What is the difference between the Number of enrolments of both sexes of Barbados in 2003 and the Number of enrolments of both sexes of Ukraine in 2005?
Provide a short and direct response. -3.70e+06. What is the difference between the Number of enrolments of both sexes in Ethiopia in 2003 and the Number of enrolments of both sexes in Mali in 2005?
Your answer should be compact. 1.40e+06. What is the difference between the Number of enrolments of both sexes in Ethiopia in 2003 and the Number of enrolments of both sexes in Ukraine in 2005?
Provide a succinct answer. -1.94e+06. What is the difference between the Number of enrolments of both sexes in Mali in 2003 and the Number of enrolments of both sexes in Ukraine in 2005?
Ensure brevity in your answer.  -3.41e+06. What is the difference between the Number of enrolments of both sexes in Barbados in 2004 and the Number of enrolments of both sexes in Ethiopia in 2005?
Offer a very short reply. -2.36e+06. What is the difference between the Number of enrolments of both sexes in Barbados in 2004 and the Number of enrolments of both sexes in Mali in 2005?
Ensure brevity in your answer.  -3.66e+05. What is the difference between the Number of enrolments of both sexes of Barbados in 2004 and the Number of enrolments of both sexes of Ukraine in 2005?
Your response must be concise. -3.70e+06. What is the difference between the Number of enrolments of both sexes of Ethiopia in 2004 and the Number of enrolments of both sexes of Mali in 2005?
Your answer should be very brief. 1.67e+06. What is the difference between the Number of enrolments of both sexes of Ethiopia in 2004 and the Number of enrolments of both sexes of Ukraine in 2005?
Keep it short and to the point. -1.67e+06. What is the difference between the Number of enrolments of both sexes of Mali in 2004 and the Number of enrolments of both sexes of Ukraine in 2005?
Offer a very short reply. -3.37e+06. What is the average Number of enrolments of both sexes of Barbados per year?
Provide a short and direct response. 2.27e+04. What is the average Number of enrolments of both sexes in Ethiopia per year?
Keep it short and to the point. 1.42e+06. What is the average Number of enrolments of both sexes of Mali per year?
Provide a succinct answer. 2.27e+05. What is the average Number of enrolments of both sexes of Ukraine per year?
Offer a terse response. 4.36e+06. In the year 1985, what is the difference between the Number of enrolments of both sexes of Barbados and Number of enrolments of both sexes of Ethiopia?
Make the answer very short. -5.74e+05. In the year 1985, what is the difference between the Number of enrolments of both sexes in Barbados and Number of enrolments of both sexes in Mali?
Give a very brief answer. -2.94e+04. In the year 1985, what is the difference between the Number of enrolments of both sexes of Barbados and Number of enrolments of both sexes of Ukraine?
Give a very brief answer. -4.19e+06. In the year 1985, what is the difference between the Number of enrolments of both sexes of Ethiopia and Number of enrolments of both sexes of Mali?
Ensure brevity in your answer.  5.44e+05. In the year 1985, what is the difference between the Number of enrolments of both sexes of Ethiopia and Number of enrolments of both sexes of Ukraine?
Your answer should be compact. -3.62e+06. In the year 1985, what is the difference between the Number of enrolments of both sexes of Mali and Number of enrolments of both sexes of Ukraine?
Offer a very short reply. -4.16e+06. In the year 1990, what is the difference between the Number of enrolments of both sexes in Barbados and Number of enrolments of both sexes in Ethiopia?
Offer a terse response. -8.46e+05. In the year 1990, what is the difference between the Number of enrolments of both sexes of Barbados and Number of enrolments of both sexes of Mali?
Your answer should be compact. -4.33e+04. In the year 1990, what is the difference between the Number of enrolments of both sexes in Barbados and Number of enrolments of both sexes in Ukraine?
Keep it short and to the point. -4.25e+06. In the year 1990, what is the difference between the Number of enrolments of both sexes of Ethiopia and Number of enrolments of both sexes of Mali?
Offer a terse response. 8.03e+05. In the year 1990, what is the difference between the Number of enrolments of both sexes of Ethiopia and Number of enrolments of both sexes of Ukraine?
Your response must be concise. -3.40e+06. In the year 1990, what is the difference between the Number of enrolments of both sexes of Mali and Number of enrolments of both sexes of Ukraine?
Offer a terse response. -4.21e+06. In the year 1999, what is the difference between the Number of enrolments of both sexes in Barbados and Number of enrolments of both sexes in Ethiopia?
Your answer should be compact. -1.03e+06. In the year 1999, what is the difference between the Number of enrolments of both sexes in Barbados and Number of enrolments of both sexes in Mali?
Offer a very short reply. -1.69e+05. In the year 1999, what is the difference between the Number of enrolments of both sexes of Barbados and Number of enrolments of both sexes of Ukraine?
Your response must be concise. -4.84e+06. In the year 1999, what is the difference between the Number of enrolments of both sexes in Ethiopia and Number of enrolments of both sexes in Mali?
Provide a succinct answer. 8.65e+05. In the year 1999, what is the difference between the Number of enrolments of both sexes in Ethiopia and Number of enrolments of both sexes in Ukraine?
Provide a short and direct response. -3.80e+06. In the year 1999, what is the difference between the Number of enrolments of both sexes of Mali and Number of enrolments of both sexes of Ukraine?
Offer a very short reply. -4.67e+06. In the year 2000, what is the difference between the Number of enrolments of both sexes in Barbados and Number of enrolments of both sexes in Ethiopia?
Provide a short and direct response. -1.17e+06. In the year 2000, what is the difference between the Number of enrolments of both sexes of Barbados and Number of enrolments of both sexes of Mali?
Provide a short and direct response. -2.04e+05. In the year 2000, what is the difference between the Number of enrolments of both sexes in Barbados and Number of enrolments of both sexes in Ukraine?
Give a very brief answer. -4.83e+06. In the year 2000, what is the difference between the Number of enrolments of both sexes of Ethiopia and Number of enrolments of both sexes of Mali?
Offer a very short reply. 9.62e+05. In the year 2000, what is the difference between the Number of enrolments of both sexes in Ethiopia and Number of enrolments of both sexes in Ukraine?
Provide a succinct answer. -3.66e+06. In the year 2000, what is the difference between the Number of enrolments of both sexes of Mali and Number of enrolments of both sexes of Ukraine?
Your answer should be compact. -4.63e+06. In the year 2003, what is the difference between the Number of enrolments of both sexes of Barbados and Number of enrolments of both sexes of Ethiopia?
Make the answer very short. -1.76e+06. In the year 2003, what is the difference between the Number of enrolments of both sexes in Barbados and Number of enrolments of both sexes in Mali?
Your answer should be compact. -2.91e+05. In the year 2003, what is the difference between the Number of enrolments of both sexes of Barbados and Number of enrolments of both sexes of Ukraine?
Make the answer very short. -4.48e+06. In the year 2003, what is the difference between the Number of enrolments of both sexes of Ethiopia and Number of enrolments of both sexes of Mali?
Provide a succinct answer. 1.47e+06. In the year 2003, what is the difference between the Number of enrolments of both sexes of Ethiopia and Number of enrolments of both sexes of Ukraine?
Offer a very short reply. -2.71e+06. In the year 2003, what is the difference between the Number of enrolments of both sexes of Mali and Number of enrolments of both sexes of Ukraine?
Offer a terse response. -4.19e+06. In the year 2004, what is the difference between the Number of enrolments of both sexes in Barbados and Number of enrolments of both sexes in Ethiopia?
Ensure brevity in your answer.  -2.03e+06. In the year 2004, what is the difference between the Number of enrolments of both sexes in Barbados and Number of enrolments of both sexes in Mali?
Make the answer very short. -3.28e+05. In the year 2004, what is the difference between the Number of enrolments of both sexes in Barbados and Number of enrolments of both sexes in Ukraine?
Your answer should be very brief. -4.11e+06. In the year 2004, what is the difference between the Number of enrolments of both sexes in Ethiopia and Number of enrolments of both sexes in Mali?
Ensure brevity in your answer.  1.70e+06. In the year 2004, what is the difference between the Number of enrolments of both sexes in Ethiopia and Number of enrolments of both sexes in Ukraine?
Provide a succinct answer. -2.07e+06. In the year 2004, what is the difference between the Number of enrolments of both sexes in Mali and Number of enrolments of both sexes in Ukraine?
Offer a terse response. -3.78e+06. In the year 2005, what is the difference between the Number of enrolments of both sexes of Barbados and Number of enrolments of both sexes of Ethiopia?
Your response must be concise. -2.36e+06. In the year 2005, what is the difference between the Number of enrolments of both sexes of Barbados and Number of enrolments of both sexes of Mali?
Offer a very short reply. -3.66e+05. In the year 2005, what is the difference between the Number of enrolments of both sexes in Barbados and Number of enrolments of both sexes in Ukraine?
Ensure brevity in your answer.  -3.70e+06. In the year 2005, what is the difference between the Number of enrolments of both sexes of Ethiopia and Number of enrolments of both sexes of Mali?
Make the answer very short. 1.99e+06. In the year 2005, what is the difference between the Number of enrolments of both sexes in Ethiopia and Number of enrolments of both sexes in Ukraine?
Give a very brief answer. -1.34e+06. In the year 2005, what is the difference between the Number of enrolments of both sexes in Mali and Number of enrolments of both sexes in Ukraine?
Make the answer very short. -3.34e+06. What is the ratio of the Number of enrolments of both sexes in Barbados in 1985 to that in 1990?
Keep it short and to the point. 1.2. What is the ratio of the Number of enrolments of both sexes of Ethiopia in 1985 to that in 1990?
Provide a short and direct response. 0.69. What is the ratio of the Number of enrolments of both sexes in Mali in 1985 to that in 1990?
Offer a terse response. 0.86. What is the ratio of the Number of enrolments of both sexes of Ukraine in 1985 to that in 1990?
Your response must be concise. 0.99. What is the ratio of the Number of enrolments of both sexes in Barbados in 1985 to that in 1999?
Ensure brevity in your answer.  1.31. What is the ratio of the Number of enrolments of both sexes in Ethiopia in 1985 to that in 1999?
Provide a succinct answer. 0.57. What is the ratio of the Number of enrolments of both sexes in Mali in 1985 to that in 1999?
Make the answer very short. 0.3. What is the ratio of the Number of enrolments of both sexes in Ukraine in 1985 to that in 1999?
Give a very brief answer. 0.87. What is the ratio of the Number of enrolments of both sexes of Barbados in 1985 to that in 2000?
Offer a very short reply. 1.37. What is the ratio of the Number of enrolments of both sexes of Ethiopia in 1985 to that in 2000?
Your answer should be very brief. 0.51. What is the ratio of the Number of enrolments of both sexes in Mali in 1985 to that in 2000?
Keep it short and to the point. 0.26. What is the ratio of the Number of enrolments of both sexes of Ukraine in 1985 to that in 2000?
Keep it short and to the point. 0.87. What is the ratio of the Number of enrolments of both sexes in Barbados in 1985 to that in 2003?
Ensure brevity in your answer.  1.38. What is the ratio of the Number of enrolments of both sexes of Ethiopia in 1985 to that in 2003?
Your answer should be compact. 0.34. What is the ratio of the Number of enrolments of both sexes in Mali in 1985 to that in 2003?
Make the answer very short. 0.19. What is the ratio of the Number of enrolments of both sexes in Ukraine in 1985 to that in 2003?
Provide a short and direct response. 0.94. What is the ratio of the Number of enrolments of both sexes in Barbados in 1985 to that in 2004?
Give a very brief answer. 1.35. What is the ratio of the Number of enrolments of both sexes in Ethiopia in 1985 to that in 2004?
Provide a short and direct response. 0.29. What is the ratio of the Number of enrolments of both sexes in Mali in 1985 to that in 2004?
Your answer should be very brief. 0.17. What is the ratio of the Number of enrolments of both sexes of Ukraine in 1985 to that in 2004?
Ensure brevity in your answer.  1.02. What is the ratio of the Number of enrolments of both sexes in Barbados in 1985 to that in 2005?
Your answer should be very brief. 1.34. What is the ratio of the Number of enrolments of both sexes of Ethiopia in 1985 to that in 2005?
Keep it short and to the point. 0.25. What is the ratio of the Number of enrolments of both sexes in Mali in 1985 to that in 2005?
Keep it short and to the point. 0.15. What is the ratio of the Number of enrolments of both sexes in Ukraine in 1985 to that in 2005?
Give a very brief answer. 1.13. What is the ratio of the Number of enrolments of both sexes of Barbados in 1990 to that in 1999?
Offer a very short reply. 1.1. What is the ratio of the Number of enrolments of both sexes of Ethiopia in 1990 to that in 1999?
Make the answer very short. 0.82. What is the ratio of the Number of enrolments of both sexes of Mali in 1990 to that in 1999?
Provide a succinct answer. 0.35. What is the ratio of the Number of enrolments of both sexes of Ukraine in 1990 to that in 1999?
Make the answer very short. 0.88. What is the ratio of the Number of enrolments of both sexes in Barbados in 1990 to that in 2000?
Keep it short and to the point. 1.14. What is the ratio of the Number of enrolments of both sexes in Ethiopia in 1990 to that in 2000?
Offer a terse response. 0.73. What is the ratio of the Number of enrolments of both sexes of Mali in 1990 to that in 2000?
Provide a short and direct response. 0.3. What is the ratio of the Number of enrolments of both sexes in Ukraine in 1990 to that in 2000?
Provide a succinct answer. 0.88. What is the ratio of the Number of enrolments of both sexes in Barbados in 1990 to that in 2003?
Ensure brevity in your answer.  1.15. What is the ratio of the Number of enrolments of both sexes in Ethiopia in 1990 to that in 2003?
Offer a terse response. 0.49. What is the ratio of the Number of enrolments of both sexes of Mali in 1990 to that in 2003?
Provide a succinct answer. 0.22. What is the ratio of the Number of enrolments of both sexes of Ukraine in 1990 to that in 2003?
Keep it short and to the point. 0.95. What is the ratio of the Number of enrolments of both sexes in Barbados in 1990 to that in 2004?
Your answer should be compact. 1.13. What is the ratio of the Number of enrolments of both sexes of Ethiopia in 1990 to that in 2004?
Your answer should be very brief. 0.42. What is the ratio of the Number of enrolments of both sexes in Mali in 1990 to that in 2004?
Offer a very short reply. 0.19. What is the ratio of the Number of enrolments of both sexes in Ukraine in 1990 to that in 2004?
Offer a terse response. 1.04. What is the ratio of the Number of enrolments of both sexes in Barbados in 1990 to that in 2005?
Provide a short and direct response. 1.12. What is the ratio of the Number of enrolments of both sexes in Ethiopia in 1990 to that in 2005?
Keep it short and to the point. 0.37. What is the ratio of the Number of enrolments of both sexes in Mali in 1990 to that in 2005?
Offer a very short reply. 0.17. What is the ratio of the Number of enrolments of both sexes in Ukraine in 1990 to that in 2005?
Your answer should be compact. 1.15. What is the ratio of the Number of enrolments of both sexes of Barbados in 1999 to that in 2000?
Give a very brief answer. 1.04. What is the ratio of the Number of enrolments of both sexes of Ethiopia in 1999 to that in 2000?
Provide a succinct answer. 0.89. What is the ratio of the Number of enrolments of both sexes in Mali in 1999 to that in 2000?
Offer a very short reply. 0.85. What is the ratio of the Number of enrolments of both sexes of Ukraine in 1999 to that in 2000?
Your answer should be very brief. 1. What is the ratio of the Number of enrolments of both sexes in Barbados in 1999 to that in 2003?
Provide a succinct answer. 1.05. What is the ratio of the Number of enrolments of both sexes in Ethiopia in 1999 to that in 2003?
Offer a terse response. 0.59. What is the ratio of the Number of enrolments of both sexes in Mali in 1999 to that in 2003?
Give a very brief answer. 0.61. What is the ratio of the Number of enrolments of both sexes in Ukraine in 1999 to that in 2003?
Your response must be concise. 1.08. What is the ratio of the Number of enrolments of both sexes in Barbados in 1999 to that in 2004?
Your answer should be compact. 1.03. What is the ratio of the Number of enrolments of both sexes in Ethiopia in 1999 to that in 2004?
Keep it short and to the point. 0.51. What is the ratio of the Number of enrolments of both sexes in Mali in 1999 to that in 2004?
Provide a succinct answer. 0.55. What is the ratio of the Number of enrolments of both sexes of Ukraine in 1999 to that in 2004?
Offer a very short reply. 1.18. What is the ratio of the Number of enrolments of both sexes in Barbados in 1999 to that in 2005?
Keep it short and to the point. 1.02. What is the ratio of the Number of enrolments of both sexes in Ethiopia in 1999 to that in 2005?
Make the answer very short. 0.44. What is the ratio of the Number of enrolments of both sexes in Mali in 1999 to that in 2005?
Provide a short and direct response. 0.49. What is the ratio of the Number of enrolments of both sexes in Ukraine in 1999 to that in 2005?
Give a very brief answer. 1.31. What is the ratio of the Number of enrolments of both sexes in Barbados in 2000 to that in 2003?
Your answer should be very brief. 1.01. What is the ratio of the Number of enrolments of both sexes of Ethiopia in 2000 to that in 2003?
Offer a very short reply. 0.66. What is the ratio of the Number of enrolments of both sexes of Mali in 2000 to that in 2003?
Offer a very short reply. 0.72. What is the ratio of the Number of enrolments of both sexes of Ukraine in 2000 to that in 2003?
Your answer should be compact. 1.08. What is the ratio of the Number of enrolments of both sexes of Barbados in 2000 to that in 2004?
Offer a terse response. 0.99. What is the ratio of the Number of enrolments of both sexes of Ethiopia in 2000 to that in 2004?
Offer a very short reply. 0.58. What is the ratio of the Number of enrolments of both sexes of Mali in 2000 to that in 2004?
Offer a very short reply. 0.64. What is the ratio of the Number of enrolments of both sexes in Ukraine in 2000 to that in 2004?
Make the answer very short. 1.18. What is the ratio of the Number of enrolments of both sexes in Barbados in 2000 to that in 2005?
Make the answer very short. 0.98. What is the ratio of the Number of enrolments of both sexes of Ethiopia in 2000 to that in 2005?
Provide a succinct answer. 0.5. What is the ratio of the Number of enrolments of both sexes in Mali in 2000 to that in 2005?
Give a very brief answer. 0.58. What is the ratio of the Number of enrolments of both sexes in Ukraine in 2000 to that in 2005?
Your response must be concise. 1.3. What is the ratio of the Number of enrolments of both sexes in Barbados in 2003 to that in 2004?
Ensure brevity in your answer.  0.98. What is the ratio of the Number of enrolments of both sexes in Ethiopia in 2003 to that in 2004?
Provide a succinct answer. 0.87. What is the ratio of the Number of enrolments of both sexes of Mali in 2003 to that in 2004?
Offer a terse response. 0.89. What is the ratio of the Number of enrolments of both sexes of Ukraine in 2003 to that in 2004?
Provide a succinct answer. 1.09. What is the ratio of the Number of enrolments of both sexes of Barbados in 2003 to that in 2005?
Provide a short and direct response. 0.98. What is the ratio of the Number of enrolments of both sexes of Ethiopia in 2003 to that in 2005?
Offer a very short reply. 0.75. What is the ratio of the Number of enrolments of both sexes in Mali in 2003 to that in 2005?
Offer a very short reply. 0.8. What is the ratio of the Number of enrolments of both sexes of Ukraine in 2003 to that in 2005?
Your response must be concise. 1.21. What is the ratio of the Number of enrolments of both sexes in Barbados in 2004 to that in 2005?
Make the answer very short. 0.99. What is the ratio of the Number of enrolments of both sexes in Ethiopia in 2004 to that in 2005?
Make the answer very short. 0.86. What is the ratio of the Number of enrolments of both sexes of Mali in 2004 to that in 2005?
Your answer should be compact. 0.9. What is the ratio of the Number of enrolments of both sexes in Ukraine in 2004 to that in 2005?
Keep it short and to the point. 1.11. What is the difference between the highest and the second highest Number of enrolments of both sexes of Barbados?
Provide a succinct answer. 4691. What is the difference between the highest and the second highest Number of enrolments of both sexes in Ethiopia?
Offer a very short reply. 3.29e+05. What is the difference between the highest and the second highest Number of enrolments of both sexes of Mali?
Your response must be concise. 3.88e+04. What is the difference between the highest and the second highest Number of enrolments of both sexes in Ukraine?
Your answer should be very brief. 8251. What is the difference between the highest and the lowest Number of enrolments of both sexes of Barbados?
Your response must be concise. 7857. What is the difference between the highest and the lowest Number of enrolments of both sexes of Ethiopia?
Provide a succinct answer. 1.78e+06. What is the difference between the highest and the lowest Number of enrolments of both sexes in Mali?
Offer a terse response. 3.29e+05. What is the difference between the highest and the lowest Number of enrolments of both sexes in Ukraine?
Ensure brevity in your answer.  1.14e+06. 